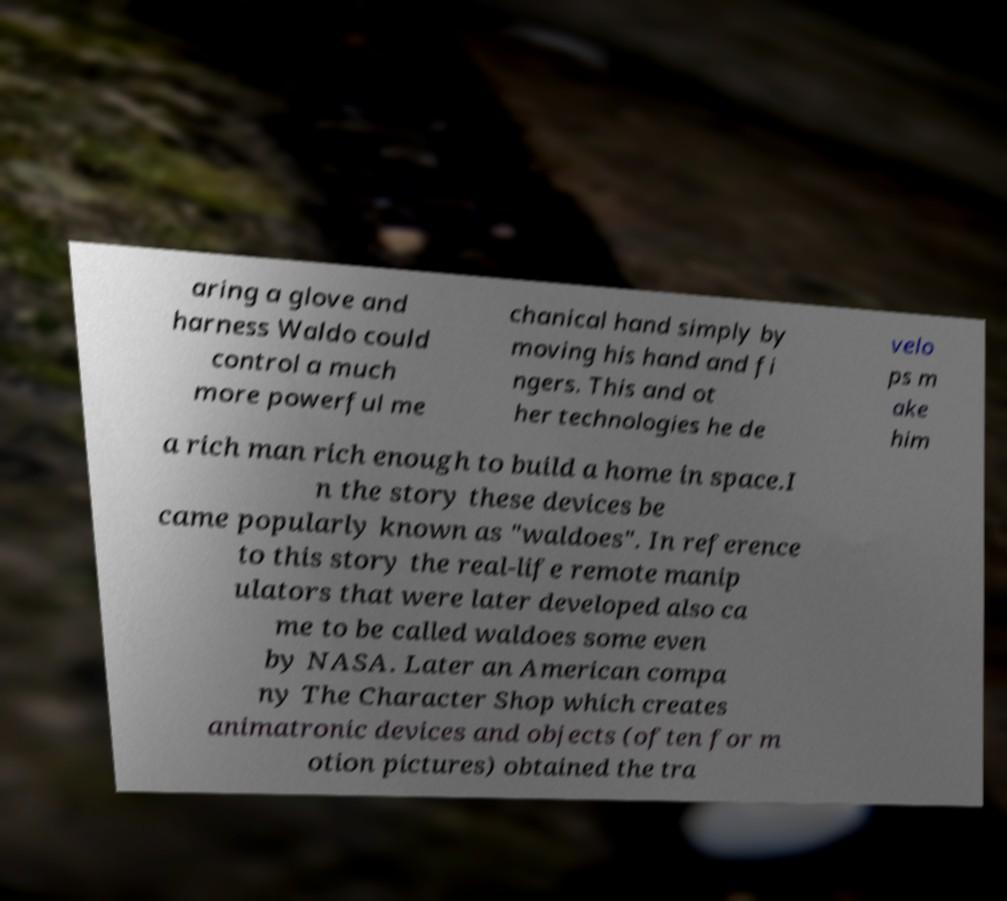For documentation purposes, I need the text within this image transcribed. Could you provide that? aring a glove and harness Waldo could control a much more powerful me chanical hand simply by moving his hand and fi ngers. This and ot her technologies he de velo ps m ake him a rich man rich enough to build a home in space.I n the story these devices be came popularly known as "waldoes". In reference to this story the real-life remote manip ulators that were later developed also ca me to be called waldoes some even by NASA. Later an American compa ny The Character Shop which creates animatronic devices and objects (often for m otion pictures) obtained the tra 